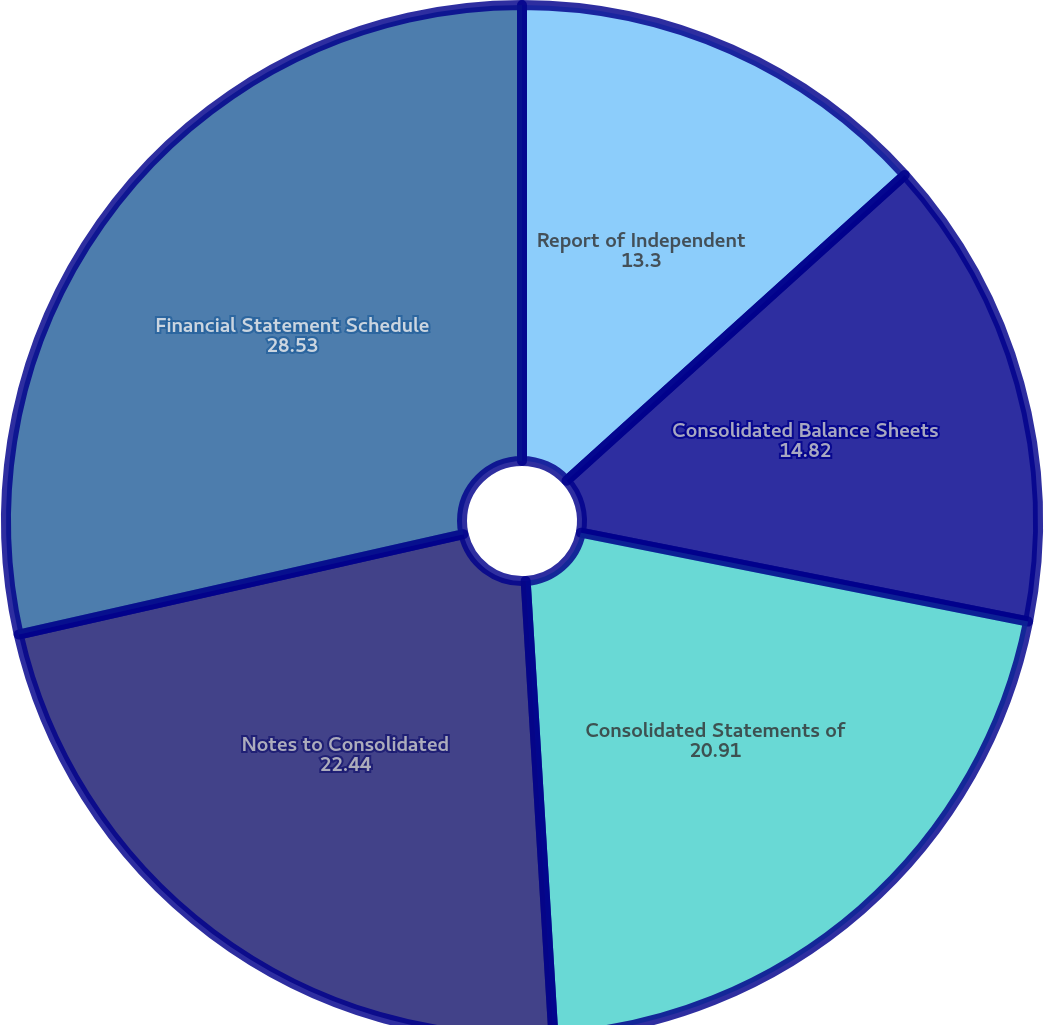Convert chart. <chart><loc_0><loc_0><loc_500><loc_500><pie_chart><fcel>Report of Independent<fcel>Consolidated Balance Sheets<fcel>Consolidated Statements of<fcel>Notes to Consolidated<fcel>Financial Statement Schedule<nl><fcel>13.3%<fcel>14.82%<fcel>20.91%<fcel>22.44%<fcel>28.53%<nl></chart> 